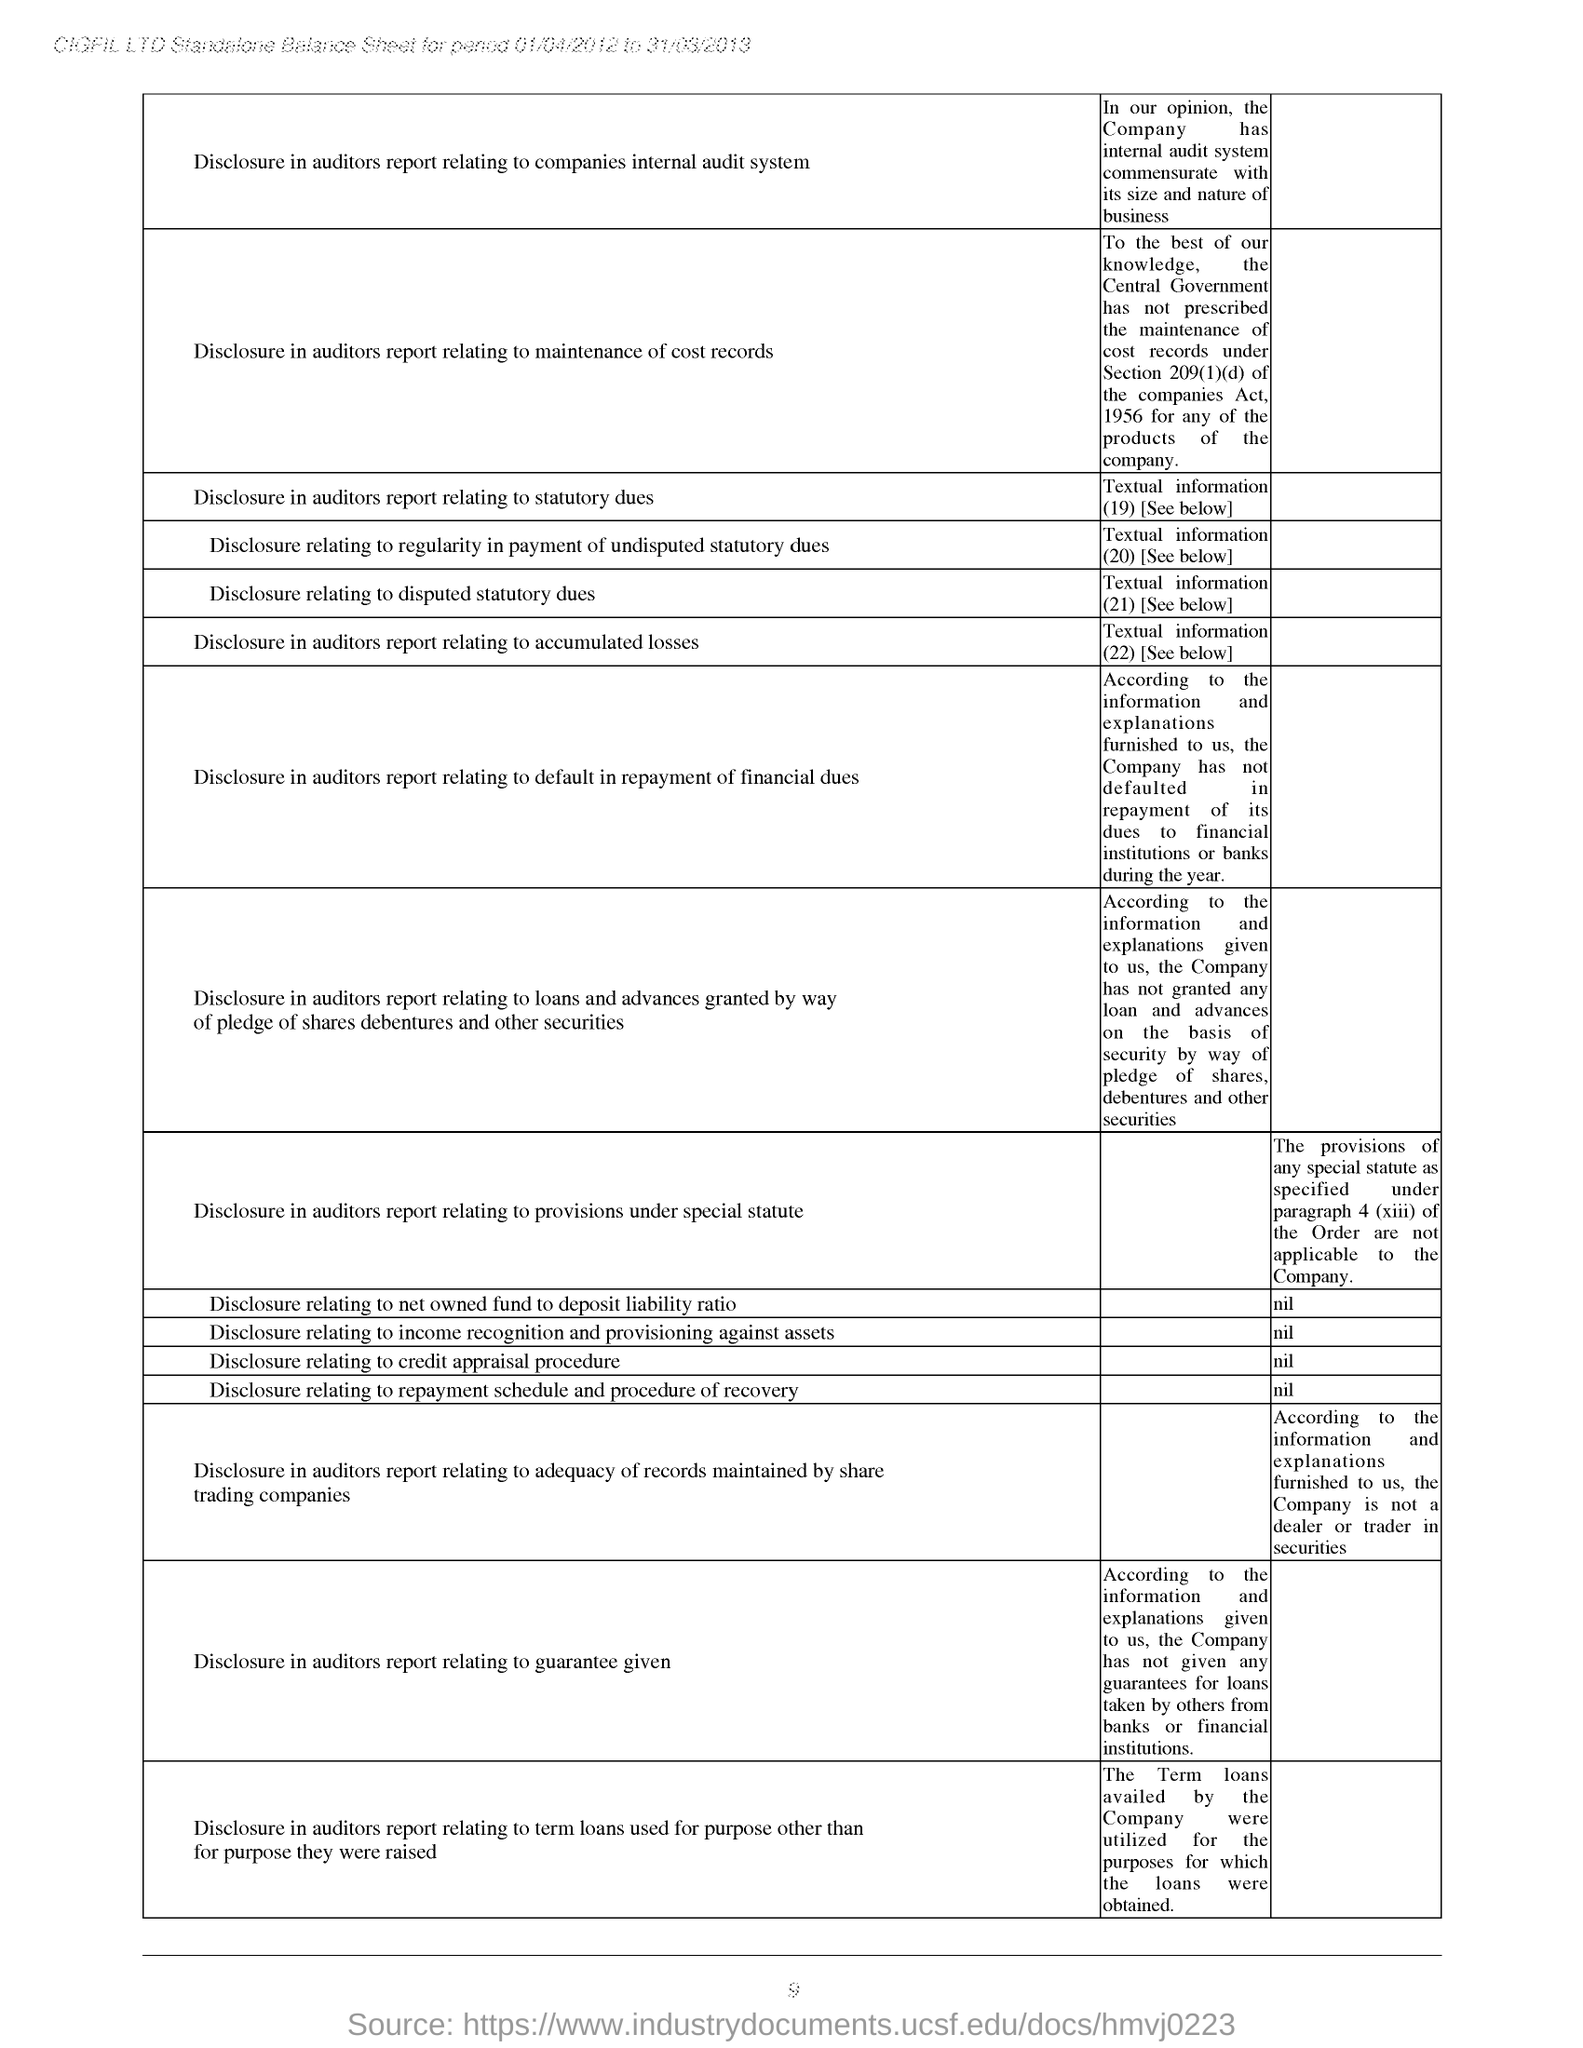Point out several critical features in this image. The first disclosure mentioned in the balance sheet is related to the auditors' report on the company's internal audit system, which is also mentioned in the auditor's report. The value entered for the disclosure relating to the net owned fund to deposit liability ratio is 'nil.' CIGFIL LTD. is the company mentioned at the top of the page. The standalone balance sheet is made for the period of 01/04/2012 to 31/03/2013. 